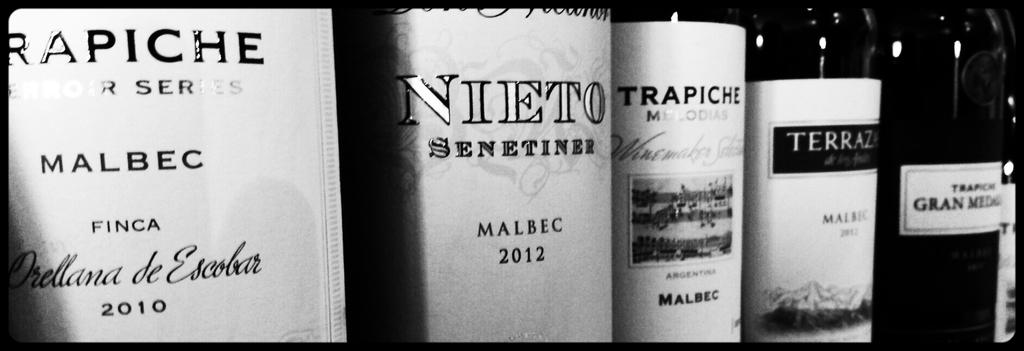<image>
Provide a brief description of the given image. several varieties of malbec next to a different bottle 